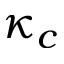<formula> <loc_0><loc_0><loc_500><loc_500>\kappa _ { c }</formula> 